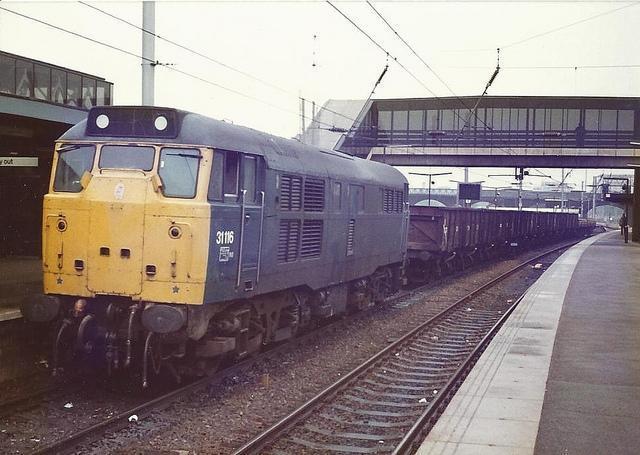How many tracks are there?
Give a very brief answer. 2. How many trains are in the picture?
Give a very brief answer. 1. How many surfboards are there?
Give a very brief answer. 0. 